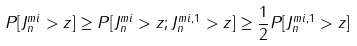<formula> <loc_0><loc_0><loc_500><loc_500>P [ J _ { n } ^ { m i } > z ] \geq P [ J _ { n } ^ { m i } > z ; J _ { n } ^ { m i , 1 } > z ] \geq \frac { 1 } { 2 } P [ J _ { n } ^ { m i , 1 } > z ]</formula> 